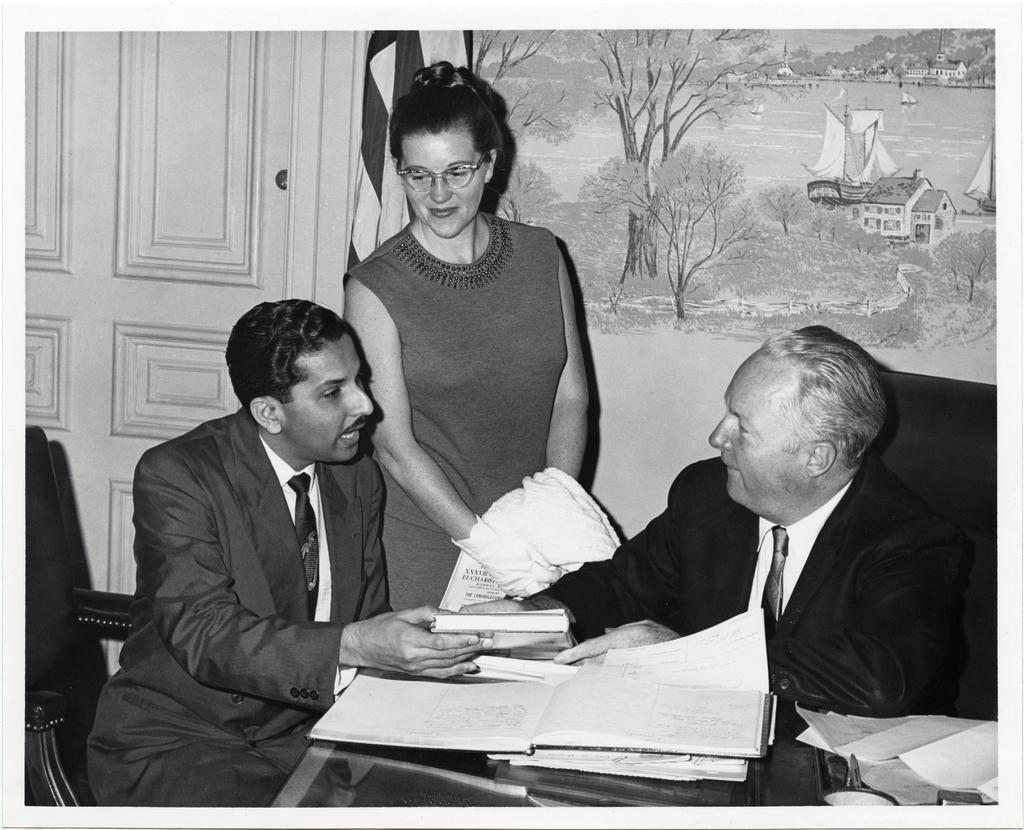In one or two sentences, can you explain what this image depicts? In this picture I can see 2 men in front, who are wearing sitting on chairs. I can see a table in front of them on which there are books and I see that both of them are holding a thing. In the background I can see a woman, who is standing and I can see the wall, on which there is an art. I can also see that this is a white and black image. 